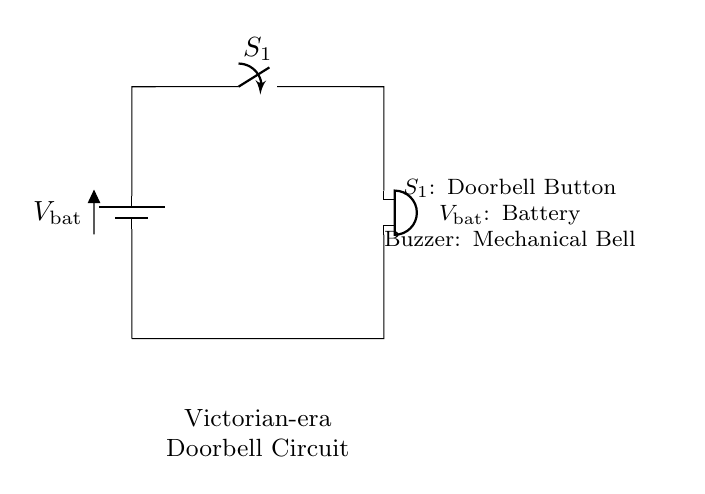What is the function of S1 in this circuit? S1 is a switch, specifically a doorbell button, which controls the flow of current when pressed. When S1 is closed, it allows the circuit to complete, activating the buzzer.
Answer: switch What type of device is represented by the buzzer? The buzzer in this circuit is a mechanical bell, which generates sound when electrical current flows through it. This happens as a result of the circuit being completed.
Answer: mechanical bell What is the source of power for this circuit? The power source is a battery, which provides the necessary voltage for the circuit to function. The battery drives current through the circuit when the switch is activated.
Answer: battery How many components are in this circuit? The circuit consists of three main components: a battery, a switch (doorbell button), and a buzzer (mechanical bell). These components work together to create the alarm system.
Answer: three What happens when S1 is closed? When S1 is closed, current flows from the battery through the circuit, enabling the buzzer to sound. This action thus initiates the alert mechanism of the doorbell.
Answer: buzzer sounds What is the voltage symbol in this circuit? The voltage symbol used in this circuit is denoted as V_bat, which indicates the battery voltage supplied to the components in the circuit.
Answer: V_bat 